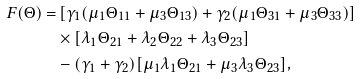Convert formula to latex. <formula><loc_0><loc_0><loc_500><loc_500>F ( \Theta ) = & \left [ \gamma _ { 1 } ( \mu _ { 1 } \Theta _ { 1 1 } + \mu _ { 3 } \Theta _ { 1 3 } ) + \gamma _ { 2 } ( \mu _ { 1 } \Theta _ { 3 1 } + \mu _ { 3 } \Theta _ { 3 3 } ) \right ] \\ & \times \left [ \lambda _ { 1 } \Theta _ { 2 1 } + \lambda _ { 2 } \Theta _ { 2 2 } + \lambda _ { 3 } \Theta _ { 2 3 } \right ] \\ & - ( \gamma _ { 1 } + \gamma _ { 2 } ) [ \mu _ { 1 } \lambda _ { 1 } \Theta _ { 2 1 } + \mu _ { 3 } \lambda _ { 3 } \Theta _ { 2 3 } ] ,</formula> 